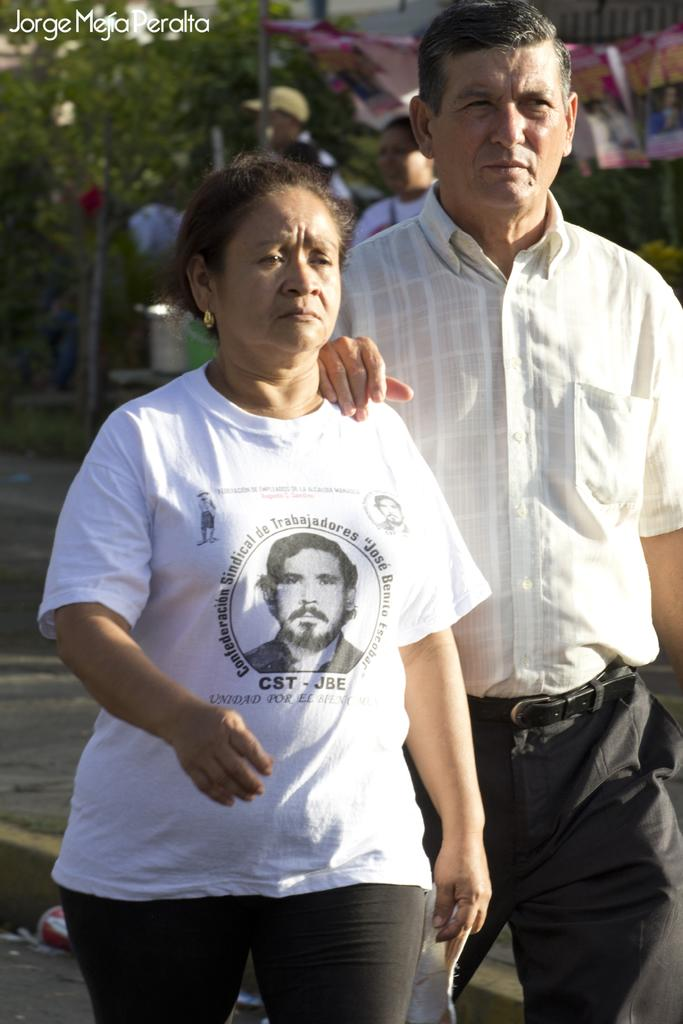Who can be seen in the foreground of the picture? There is a couple in the foreground of the picture. What are the couple doing in the image? The couple is walking on the road. What can be seen in the background of the picture? There is a tent, a person, a pole, and trees in the background of the picture. What type of dress is the person in jail wearing in the image? There is no person in jail present in the image, and therefore no dress can be observed. 